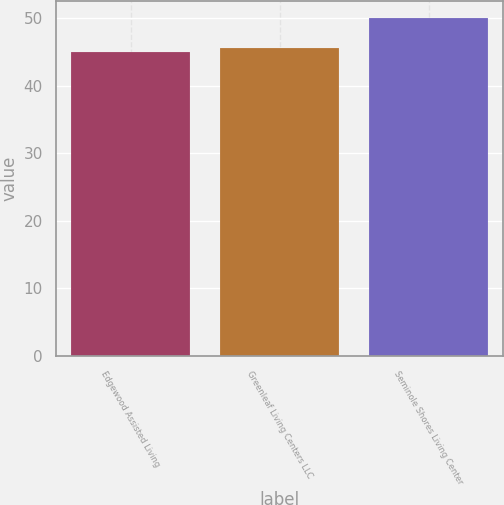Convert chart. <chart><loc_0><loc_0><loc_500><loc_500><bar_chart><fcel>Edgewood Assisted Living<fcel>Greenleaf Living Centers LLC<fcel>Seminole Shores Living Center<nl><fcel>45<fcel>45.5<fcel>50<nl></chart> 